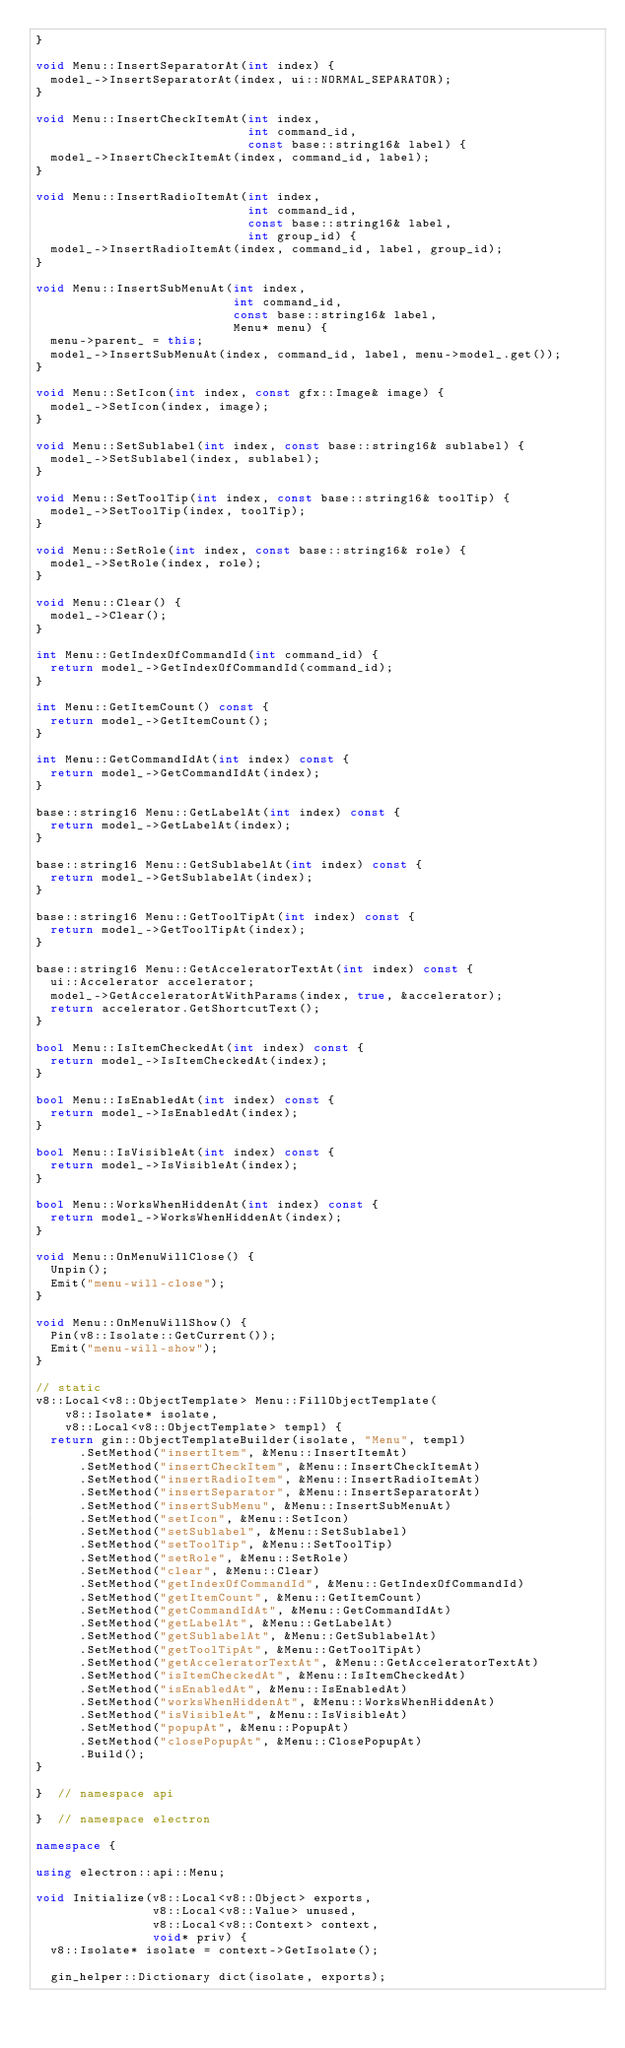Convert code to text. <code><loc_0><loc_0><loc_500><loc_500><_C++_>}

void Menu::InsertSeparatorAt(int index) {
  model_->InsertSeparatorAt(index, ui::NORMAL_SEPARATOR);
}

void Menu::InsertCheckItemAt(int index,
                             int command_id,
                             const base::string16& label) {
  model_->InsertCheckItemAt(index, command_id, label);
}

void Menu::InsertRadioItemAt(int index,
                             int command_id,
                             const base::string16& label,
                             int group_id) {
  model_->InsertRadioItemAt(index, command_id, label, group_id);
}

void Menu::InsertSubMenuAt(int index,
                           int command_id,
                           const base::string16& label,
                           Menu* menu) {
  menu->parent_ = this;
  model_->InsertSubMenuAt(index, command_id, label, menu->model_.get());
}

void Menu::SetIcon(int index, const gfx::Image& image) {
  model_->SetIcon(index, image);
}

void Menu::SetSublabel(int index, const base::string16& sublabel) {
  model_->SetSublabel(index, sublabel);
}

void Menu::SetToolTip(int index, const base::string16& toolTip) {
  model_->SetToolTip(index, toolTip);
}

void Menu::SetRole(int index, const base::string16& role) {
  model_->SetRole(index, role);
}

void Menu::Clear() {
  model_->Clear();
}

int Menu::GetIndexOfCommandId(int command_id) {
  return model_->GetIndexOfCommandId(command_id);
}

int Menu::GetItemCount() const {
  return model_->GetItemCount();
}

int Menu::GetCommandIdAt(int index) const {
  return model_->GetCommandIdAt(index);
}

base::string16 Menu::GetLabelAt(int index) const {
  return model_->GetLabelAt(index);
}

base::string16 Menu::GetSublabelAt(int index) const {
  return model_->GetSublabelAt(index);
}

base::string16 Menu::GetToolTipAt(int index) const {
  return model_->GetToolTipAt(index);
}

base::string16 Menu::GetAcceleratorTextAt(int index) const {
  ui::Accelerator accelerator;
  model_->GetAcceleratorAtWithParams(index, true, &accelerator);
  return accelerator.GetShortcutText();
}

bool Menu::IsItemCheckedAt(int index) const {
  return model_->IsItemCheckedAt(index);
}

bool Menu::IsEnabledAt(int index) const {
  return model_->IsEnabledAt(index);
}

bool Menu::IsVisibleAt(int index) const {
  return model_->IsVisibleAt(index);
}

bool Menu::WorksWhenHiddenAt(int index) const {
  return model_->WorksWhenHiddenAt(index);
}

void Menu::OnMenuWillClose() {
  Unpin();
  Emit("menu-will-close");
}

void Menu::OnMenuWillShow() {
  Pin(v8::Isolate::GetCurrent());
  Emit("menu-will-show");
}

// static
v8::Local<v8::ObjectTemplate> Menu::FillObjectTemplate(
    v8::Isolate* isolate,
    v8::Local<v8::ObjectTemplate> templ) {
  return gin::ObjectTemplateBuilder(isolate, "Menu", templ)
      .SetMethod("insertItem", &Menu::InsertItemAt)
      .SetMethod("insertCheckItem", &Menu::InsertCheckItemAt)
      .SetMethod("insertRadioItem", &Menu::InsertRadioItemAt)
      .SetMethod("insertSeparator", &Menu::InsertSeparatorAt)
      .SetMethod("insertSubMenu", &Menu::InsertSubMenuAt)
      .SetMethod("setIcon", &Menu::SetIcon)
      .SetMethod("setSublabel", &Menu::SetSublabel)
      .SetMethod("setToolTip", &Menu::SetToolTip)
      .SetMethod("setRole", &Menu::SetRole)
      .SetMethod("clear", &Menu::Clear)
      .SetMethod("getIndexOfCommandId", &Menu::GetIndexOfCommandId)
      .SetMethod("getItemCount", &Menu::GetItemCount)
      .SetMethod("getCommandIdAt", &Menu::GetCommandIdAt)
      .SetMethod("getLabelAt", &Menu::GetLabelAt)
      .SetMethod("getSublabelAt", &Menu::GetSublabelAt)
      .SetMethod("getToolTipAt", &Menu::GetToolTipAt)
      .SetMethod("getAcceleratorTextAt", &Menu::GetAcceleratorTextAt)
      .SetMethod("isItemCheckedAt", &Menu::IsItemCheckedAt)
      .SetMethod("isEnabledAt", &Menu::IsEnabledAt)
      .SetMethod("worksWhenHiddenAt", &Menu::WorksWhenHiddenAt)
      .SetMethod("isVisibleAt", &Menu::IsVisibleAt)
      .SetMethod("popupAt", &Menu::PopupAt)
      .SetMethod("closePopupAt", &Menu::ClosePopupAt)
      .Build();
}

}  // namespace api

}  // namespace electron

namespace {

using electron::api::Menu;

void Initialize(v8::Local<v8::Object> exports,
                v8::Local<v8::Value> unused,
                v8::Local<v8::Context> context,
                void* priv) {
  v8::Isolate* isolate = context->GetIsolate();

  gin_helper::Dictionary dict(isolate, exports);</code> 